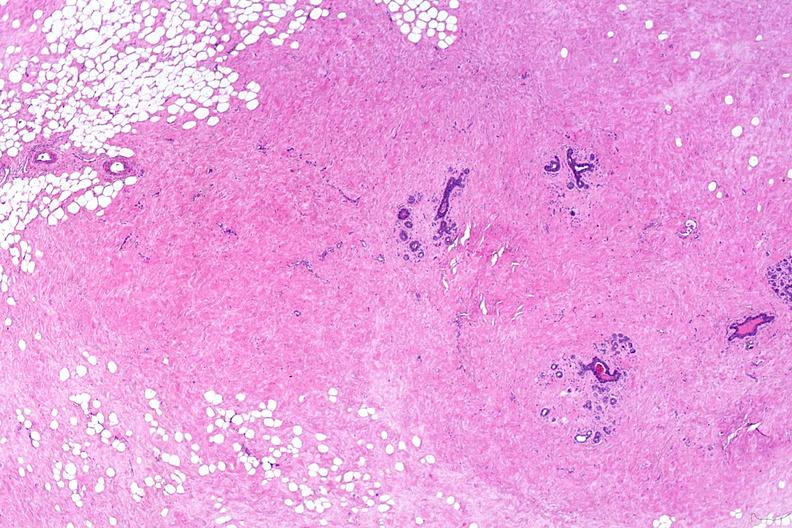s infant body present?
Answer the question using a single word or phrase. No 